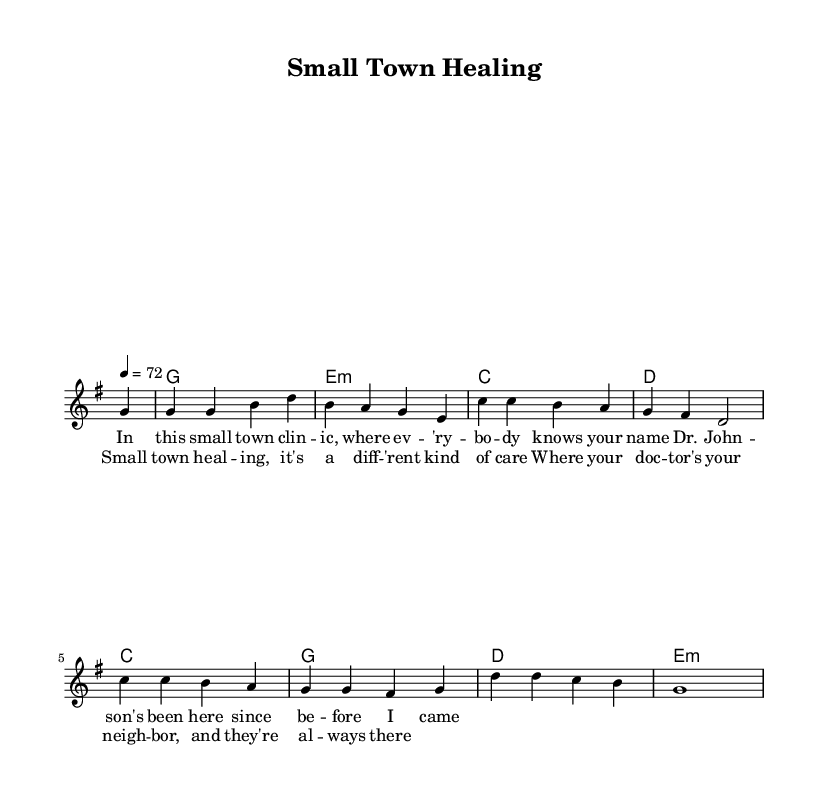What is the key signature of this music? The key signature is indicated at the beginning of the score and shows that there is one sharp, which corresponds to the key of G major.
Answer: G major What is the time signature of this music? The time signature appears at the beginning of the score and indicates that there are four beats in every measure, which is shown as 4/4.
Answer: 4/4 What is the tempo marking for this piece? The tempo marking is indicated in the global settings as "4 = 72", meaning there are 72 beats per minute, which is a moderate speed.
Answer: 72 Which section in the lyrics mentions the doctor's name? The lyrics specifically mention "Dr. Johnson" in the first verse, indicating a personal connection in the small-town healthcare theme.
Answer: Dr. Johnson How many chords are used in the harmonic progression? By examining the harmonic section, there are four unique chords that are repeated within the progression: G, E minor, C, and D. The pattern indicates a common chord structure.
Answer: Four What theme do the lyrics primarily express about healthcare? The lyrics focus on the sense of community and personal connection in small-town healthcare, emphasizing familiarity and care from local doctors.
Answer: Community care What is the overall mood suggested by the chorus? The chorus expresses feelings of warmth and reassurance that come from having a local doctor who is always available, suggesting a nostalgic and caring atmosphere.
Answer: Nostalgic and caring 